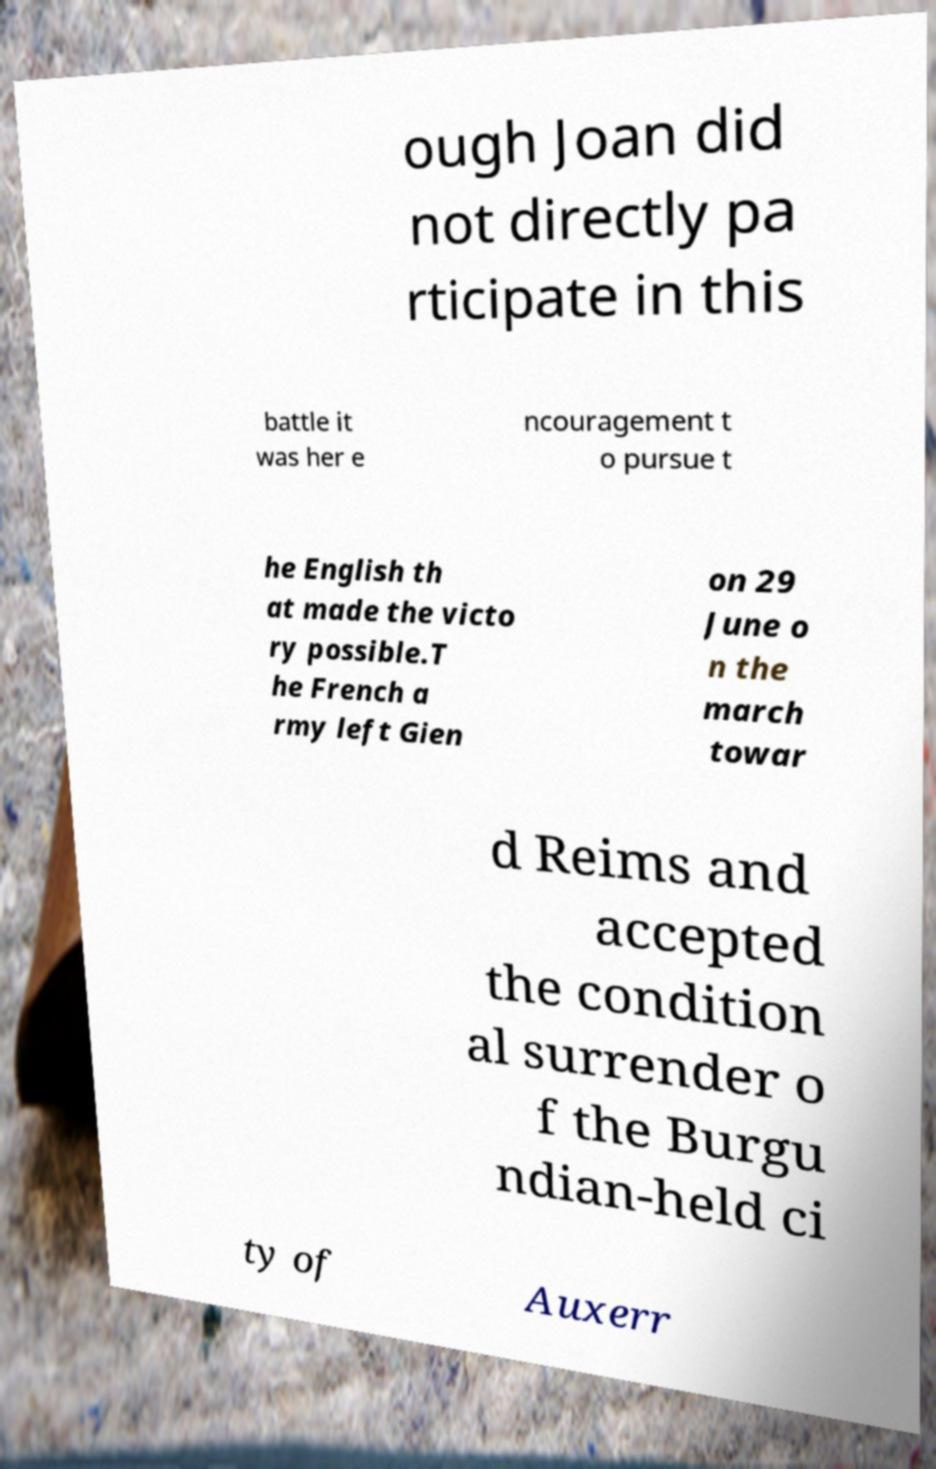Could you assist in decoding the text presented in this image and type it out clearly? ough Joan did not directly pa rticipate in this battle it was her e ncouragement t o pursue t he English th at made the victo ry possible.T he French a rmy left Gien on 29 June o n the march towar d Reims and accepted the condition al surrender o f the Burgu ndian-held ci ty of Auxerr 